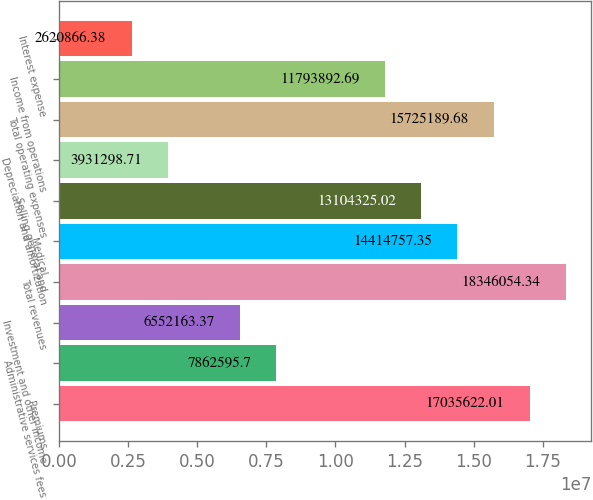<chart> <loc_0><loc_0><loc_500><loc_500><bar_chart><fcel>Premiums<fcel>Administrative services fees<fcel>Investment and other income<fcel>Total revenues<fcel>Medical<fcel>Selling general and<fcel>Depreciation and amortization<fcel>Total operating expenses<fcel>Income from operations<fcel>Interest expense<nl><fcel>1.70356e+07<fcel>7.8626e+06<fcel>6.55216e+06<fcel>1.83461e+07<fcel>1.44148e+07<fcel>1.31043e+07<fcel>3.9313e+06<fcel>1.57252e+07<fcel>1.17939e+07<fcel>2.62087e+06<nl></chart> 